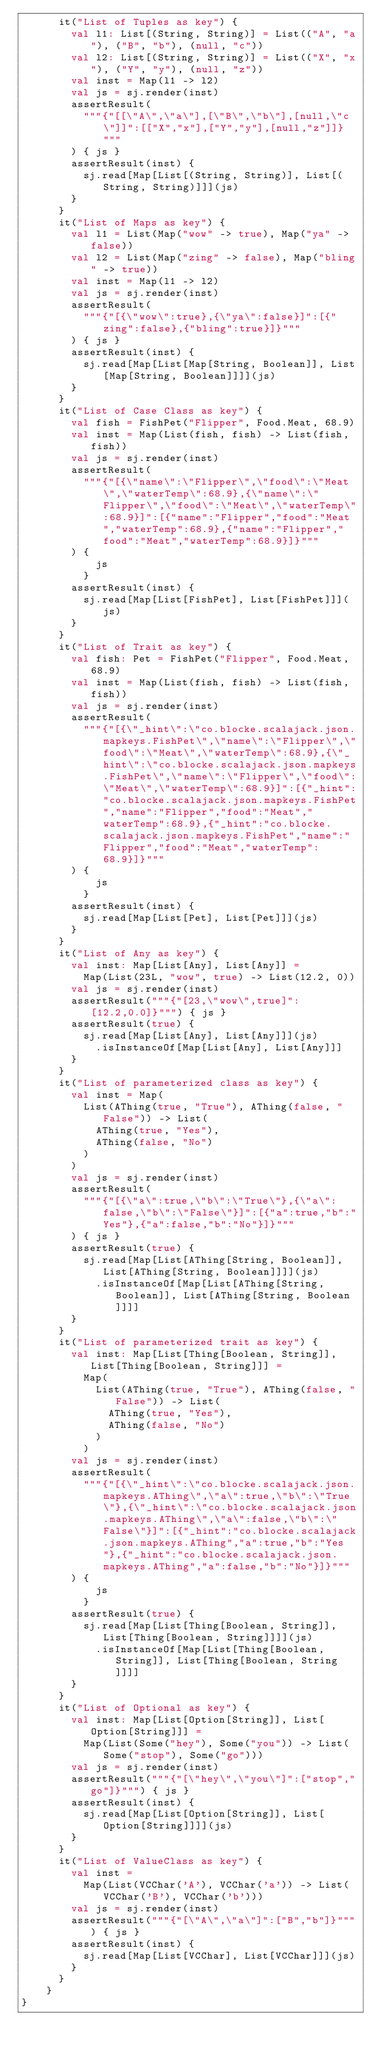<code> <loc_0><loc_0><loc_500><loc_500><_Scala_>      it("List of Tuples as key") {
        val l1: List[(String, String)] = List(("A", "a"), ("B", "b"), (null, "c"))
        val l2: List[(String, String)] = List(("X", "x"), ("Y", "y"), (null, "z"))
        val inst = Map(l1 -> l2)
        val js = sj.render(inst)
        assertResult(
          """{"[[\"A\",\"a\"],[\"B\",\"b\"],[null,\"c\"]]":[["X","x"],["Y","y"],[null,"z"]]}"""
        ) { js }
        assertResult(inst) {
          sj.read[Map[List[(String, String)], List[(String, String)]]](js)
        }
      }
      it("List of Maps as key") {
        val l1 = List(Map("wow" -> true), Map("ya" -> false))
        val l2 = List(Map("zing" -> false), Map("bling" -> true))
        val inst = Map(l1 -> l2)
        val js = sj.render(inst)
        assertResult(
          """{"[{\"wow\":true},{\"ya\":false}]":[{"zing":false},{"bling":true}]}"""
        ) { js }
        assertResult(inst) {
          sj.read[Map[List[Map[String, Boolean]], List[Map[String, Boolean]]]](js)
        }
      }
      it("List of Case Class as key") {
        val fish = FishPet("Flipper", Food.Meat, 68.9)
        val inst = Map(List(fish, fish) -> List(fish, fish))
        val js = sj.render(inst)
        assertResult(
          """{"[{\"name\":\"Flipper\",\"food\":\"Meat\",\"waterTemp\":68.9},{\"name\":\"Flipper\",\"food\":\"Meat\",\"waterTemp\":68.9}]":[{"name":"Flipper","food":"Meat","waterTemp":68.9},{"name":"Flipper","food":"Meat","waterTemp":68.9}]}"""
        ) {
            js
          }
        assertResult(inst) {
          sj.read[Map[List[FishPet], List[FishPet]]](js)
        }
      }
      it("List of Trait as key") {
        val fish: Pet = FishPet("Flipper", Food.Meat, 68.9)
        val inst = Map(List(fish, fish) -> List(fish, fish))
        val js = sj.render(inst)
        assertResult(
          """{"[{\"_hint\":\"co.blocke.scalajack.json.mapkeys.FishPet\",\"name\":\"Flipper\",\"food\":\"Meat\",\"waterTemp\":68.9},{\"_hint\":\"co.blocke.scalajack.json.mapkeys.FishPet\",\"name\":\"Flipper\",\"food\":\"Meat\",\"waterTemp\":68.9}]":[{"_hint":"co.blocke.scalajack.json.mapkeys.FishPet","name":"Flipper","food":"Meat","waterTemp":68.9},{"_hint":"co.blocke.scalajack.json.mapkeys.FishPet","name":"Flipper","food":"Meat","waterTemp":68.9}]}"""
        ) {
            js
          }
        assertResult(inst) {
          sj.read[Map[List[Pet], List[Pet]]](js)
        }
      }
      it("List of Any as key") {
        val inst: Map[List[Any], List[Any]] =
          Map(List(23L, "wow", true) -> List(12.2, 0))
        val js = sj.render(inst)
        assertResult("""{"[23,\"wow\",true]":[12.2,0.0]}""") { js }
        assertResult(true) {
          sj.read[Map[List[Any], List[Any]]](js)
            .isInstanceOf[Map[List[Any], List[Any]]]
        }
      }
      it("List of parameterized class as key") {
        val inst = Map(
          List(AThing(true, "True"), AThing(false, "False")) -> List(
            AThing(true, "Yes"),
            AThing(false, "No")
          )
        )
        val js = sj.render(inst)
        assertResult(
          """{"[{\"a\":true,\"b\":\"True\"},{\"a\":false,\"b\":\"False\"}]":[{"a":true,"b":"Yes"},{"a":false,"b":"No"}]}"""
        ) { js }
        assertResult(true) {
          sj.read[Map[List[AThing[String, Boolean]], List[AThing[String, Boolean]]]](js)
            .isInstanceOf[Map[List[AThing[String, Boolean]], List[AThing[String, Boolean]]]]
        }
      }
      it("List of parameterized trait as key") {
        val inst: Map[List[Thing[Boolean, String]], List[Thing[Boolean, String]]] =
          Map(
            List(AThing(true, "True"), AThing(false, "False")) -> List(
              AThing(true, "Yes"),
              AThing(false, "No")
            )
          )
        val js = sj.render(inst)
        assertResult(
          """{"[{\"_hint\":\"co.blocke.scalajack.json.mapkeys.AThing\",\"a\":true,\"b\":\"True\"},{\"_hint\":\"co.blocke.scalajack.json.mapkeys.AThing\",\"a\":false,\"b\":\"False\"}]":[{"_hint":"co.blocke.scalajack.json.mapkeys.AThing","a":true,"b":"Yes"},{"_hint":"co.blocke.scalajack.json.mapkeys.AThing","a":false,"b":"No"}]}"""
        ) {
            js
          }
        assertResult(true) {
          sj.read[Map[List[Thing[Boolean, String]], List[Thing[Boolean, String]]]](js)
            .isInstanceOf[Map[List[Thing[Boolean, String]], List[Thing[Boolean, String]]]]
        }
      }
      it("List of Optional as key") {
        val inst: Map[List[Option[String]], List[Option[String]]] =
          Map(List(Some("hey"), Some("you")) -> List(Some("stop"), Some("go")))
        val js = sj.render(inst)
        assertResult("""{"[\"hey\",\"you\"]":["stop","go"]}""") { js }
        assertResult(inst) {
          sj.read[Map[List[Option[String]], List[Option[String]]]](js)
        }
      }
      it("List of ValueClass as key") {
        val inst =
          Map(List(VCChar('A'), VCChar('a')) -> List(VCChar('B'), VCChar('b')))
        val js = sj.render(inst)
        assertResult("""{"[\"A\",\"a\"]":["B","b"]}""") { js }
        assertResult(inst) {
          sj.read[Map[List[VCChar], List[VCChar]]](js)
        }
      }
    }
}
</code> 